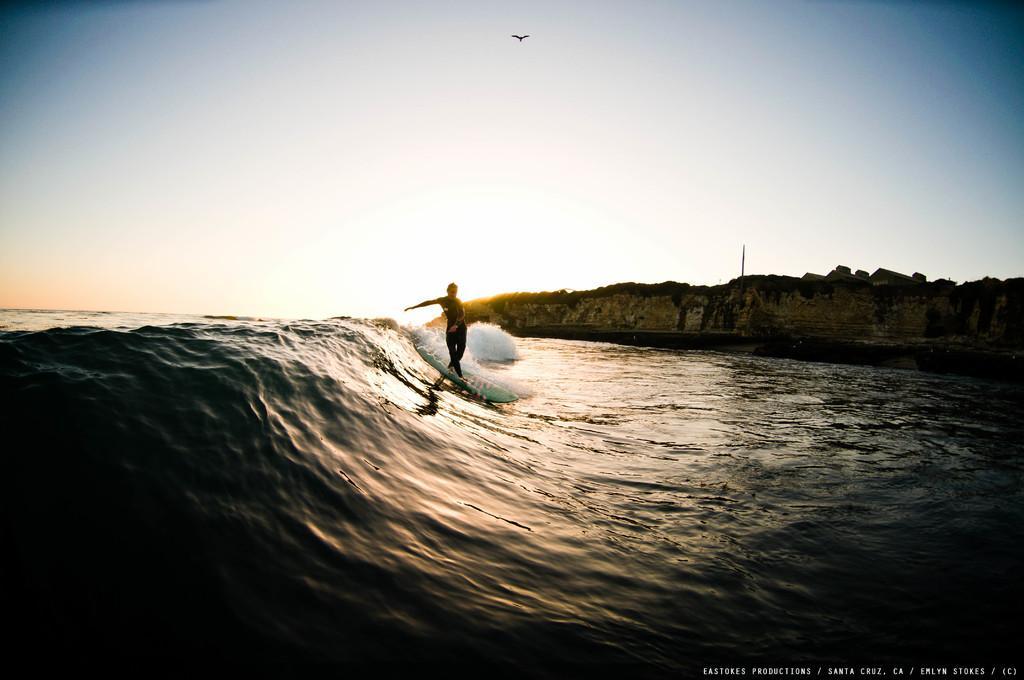How would you summarize this image in a sentence or two? In the center of the image we can see a person surfing on the sea. On the right there is a rock. In the background there is sky and we can see a bird flying in the sky. 